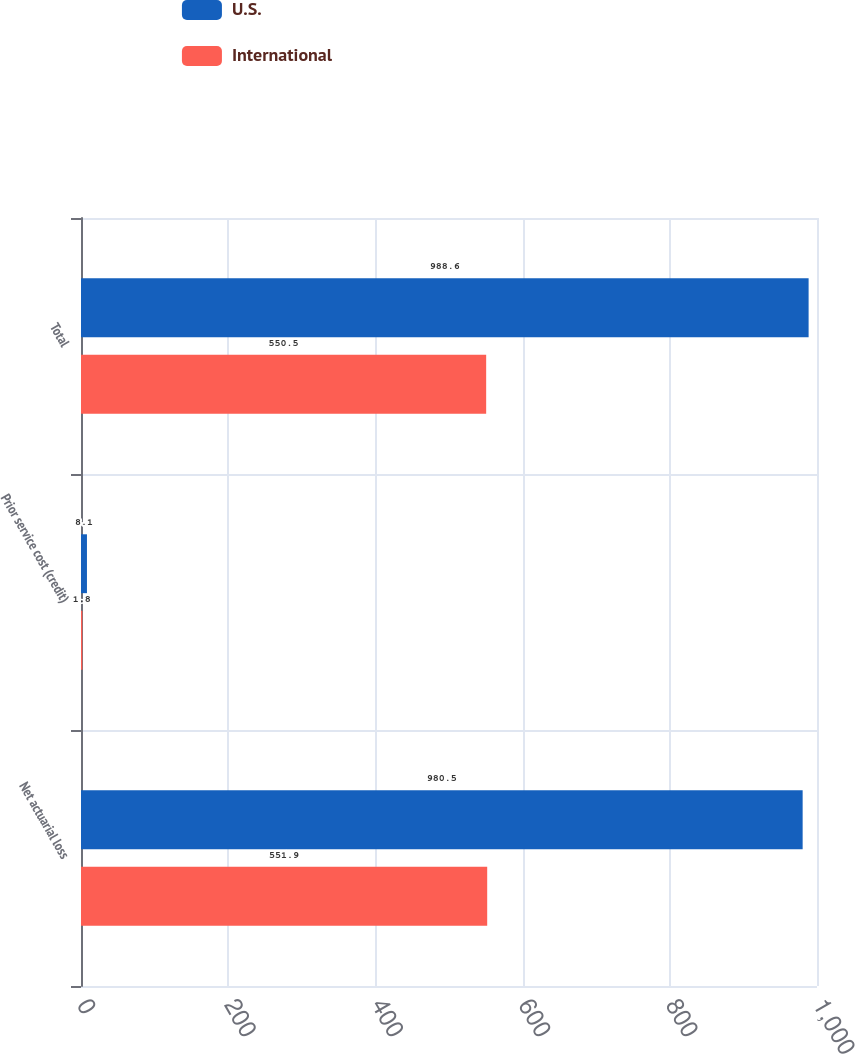<chart> <loc_0><loc_0><loc_500><loc_500><stacked_bar_chart><ecel><fcel>Net actuarial loss<fcel>Prior service cost (credit)<fcel>Total<nl><fcel>U.S.<fcel>980.5<fcel>8.1<fcel>988.6<nl><fcel>International<fcel>551.9<fcel>1.8<fcel>550.5<nl></chart> 